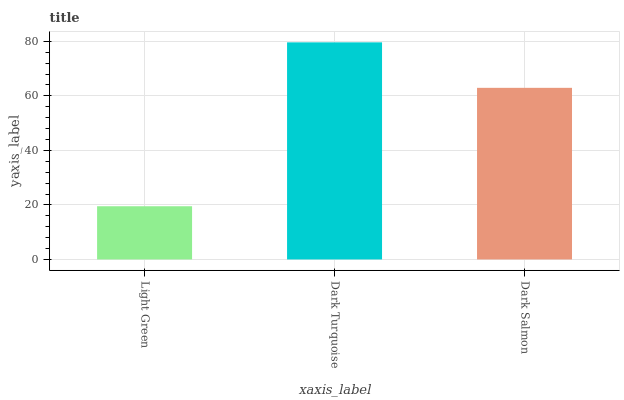Is Light Green the minimum?
Answer yes or no. Yes. Is Dark Turquoise the maximum?
Answer yes or no. Yes. Is Dark Salmon the minimum?
Answer yes or no. No. Is Dark Salmon the maximum?
Answer yes or no. No. Is Dark Turquoise greater than Dark Salmon?
Answer yes or no. Yes. Is Dark Salmon less than Dark Turquoise?
Answer yes or no. Yes. Is Dark Salmon greater than Dark Turquoise?
Answer yes or no. No. Is Dark Turquoise less than Dark Salmon?
Answer yes or no. No. Is Dark Salmon the high median?
Answer yes or no. Yes. Is Dark Salmon the low median?
Answer yes or no. Yes. Is Dark Turquoise the high median?
Answer yes or no. No. Is Light Green the low median?
Answer yes or no. No. 